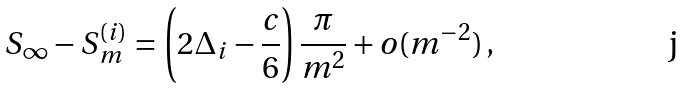<formula> <loc_0><loc_0><loc_500><loc_500>S _ { \infty } - S ^ { ( i ) } _ { m } = \left ( 2 \Delta _ { i } - \frac { c } { 6 } \right ) \frac { \pi } { m ^ { 2 } } + o ( m ^ { - 2 } ) \, ,</formula> 